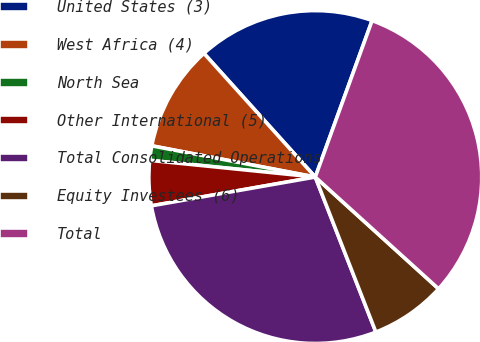Convert chart. <chart><loc_0><loc_0><loc_500><loc_500><pie_chart><fcel>United States (3)<fcel>West Africa (4)<fcel>North Sea<fcel>Other International (5)<fcel>Total Consolidated Operations<fcel>Equity Investees (6)<fcel>Total<nl><fcel>17.21%<fcel>10.33%<fcel>1.4%<fcel>4.37%<fcel>28.16%<fcel>7.35%<fcel>31.18%<nl></chart> 